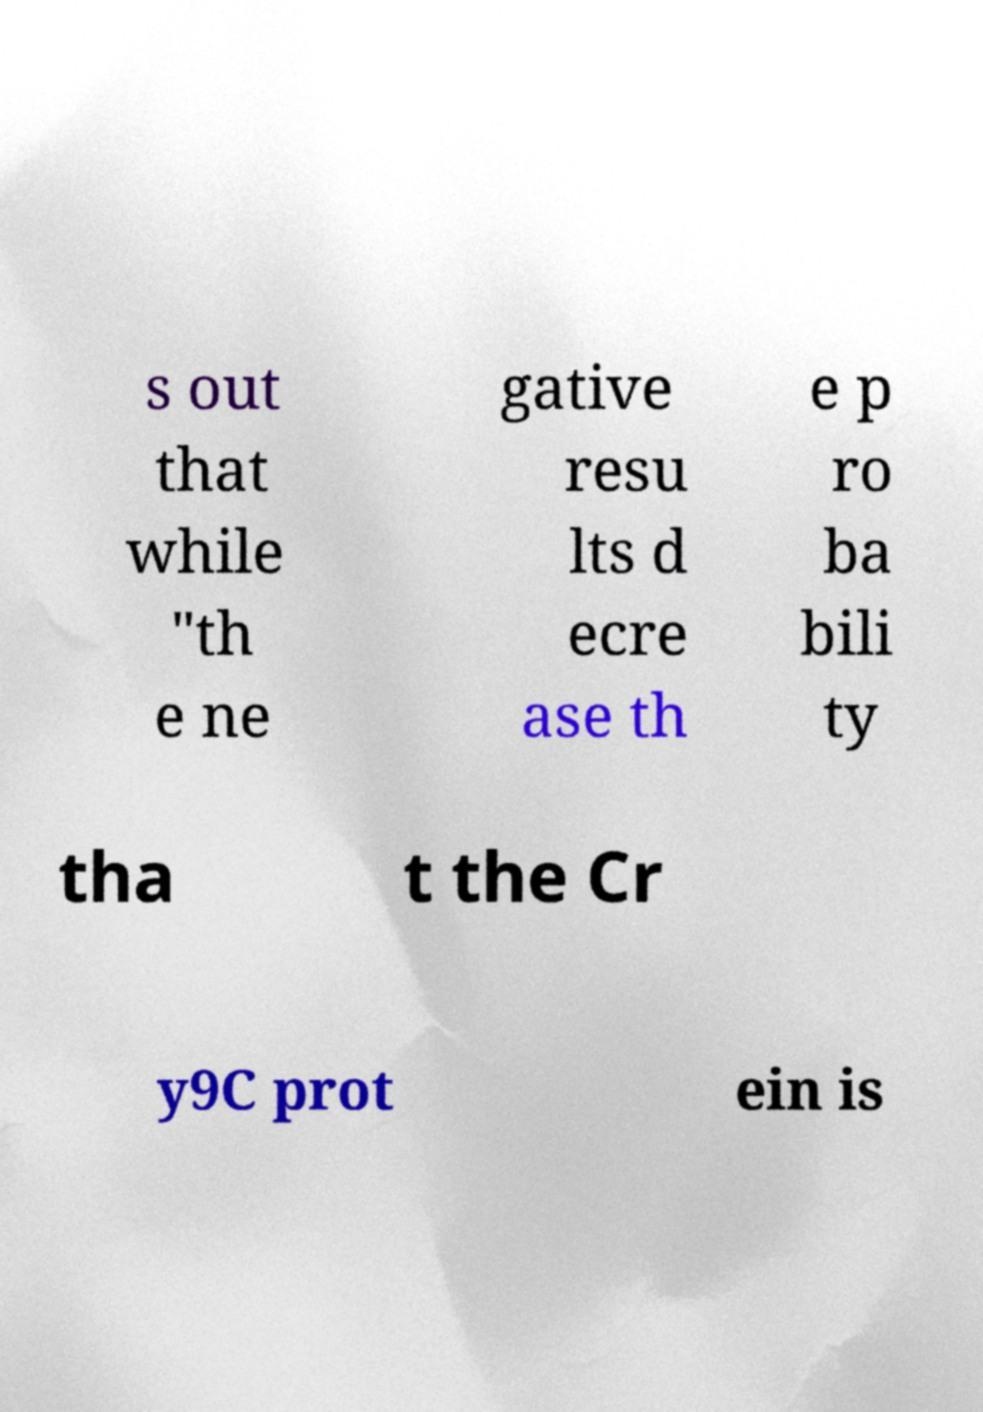Can you accurately transcribe the text from the provided image for me? s out that while "th e ne gative resu lts d ecre ase th e p ro ba bili ty tha t the Cr y9C prot ein is 